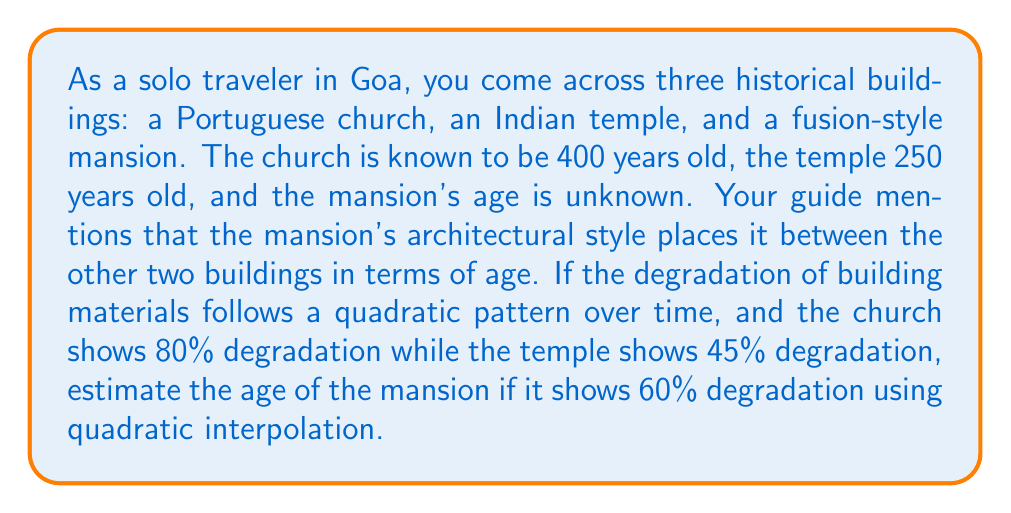Could you help me with this problem? To solve this problem, we'll use quadratic interpolation. Let's follow these steps:

1) Define our variables:
   $x$ = age of building
   $y$ = degradation percentage
   
   We have three points:
   $(x_1, y_1) = (250, 45)$ for the temple
   $(x_2, y_2) = (x, 60)$ for the mansion (x is unknown)
   $(x_3, y_3) = (400, 80)$ for the church

2) The quadratic interpolation formula is:
   $$y = a(x-x_1)(x-x_3) + b(x-x_1)(x-x_2) + c(x-x_2)(x-x_3)$$

   Where:
   $$a = \frac{y_2}{(x_2-x_1)(x_2-x_3)}$$
   $$b = \frac{y_1}{(x_1-x_2)(x_1-x_3)}$$
   $$c = \frac{y_3}{(x_3-x_1)(x_3-x_2)}$$

3) Substitute the known values:
   $$60 = \frac{60}{(x-250)(x-400)} (x-250)(x-400) + \frac{45}{(250-x)(250-400)} (x-250)(x-400) + \frac{80}{(400-250)(400-x)} (x-250)(x-400)$$

4) Simplify:
   $$60 = 60 + \frac{45(x-400)}{(x-400)} + \frac{80(x-250)}{(400-x)}$$

5) Further simplification:
   $$0 = 45 + \frac{80(x-250)}{(400-x)}$$

6) Multiply both sides by $(400-x)$:
   $$0 = 45(400-x) + 80(x-250)$$

7) Expand:
   $$0 = 18000 - 45x + 80x - 20000$$

8) Simplify:
   $$0 = -2000 + 35x$$

9) Solve for x:
   $$x = \frac{2000}{35} \approx 314.29$$

Therefore, the estimated age of the mansion is approximately 314 years.
Answer: 314 years 